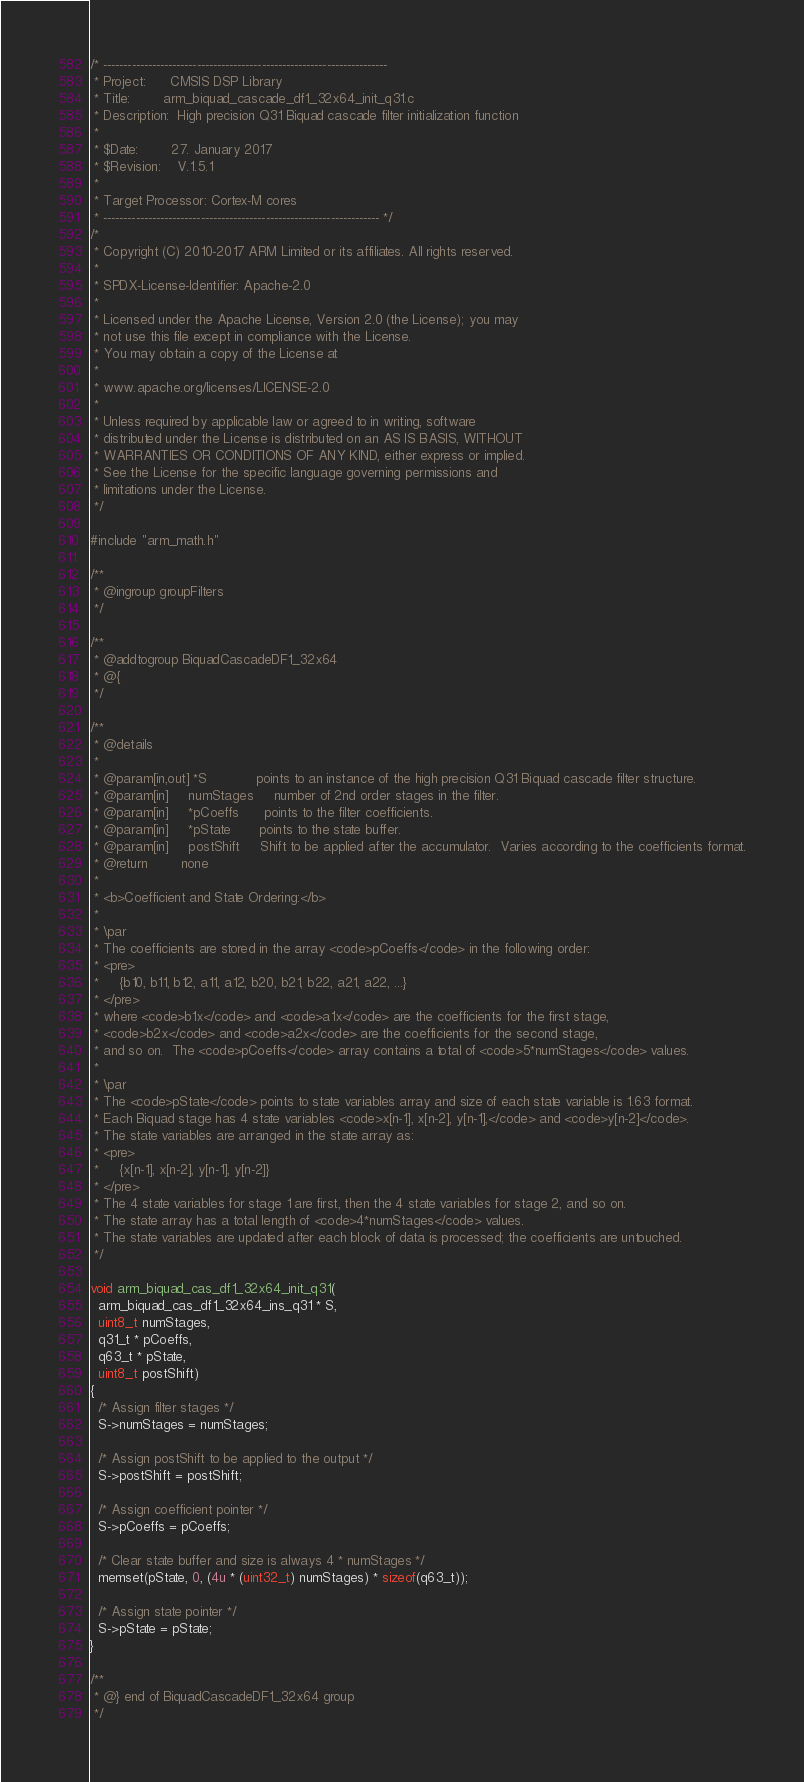<code> <loc_0><loc_0><loc_500><loc_500><_C_>/* ----------------------------------------------------------------------
 * Project:      CMSIS DSP Library
 * Title:        arm_biquad_cascade_df1_32x64_init_q31.c
 * Description:  High precision Q31 Biquad cascade filter initialization function
 *
 * $Date:        27. January 2017
 * $Revision:    V.1.5.1
 *
 * Target Processor: Cortex-M cores
 * -------------------------------------------------------------------- */
/*
 * Copyright (C) 2010-2017 ARM Limited or its affiliates. All rights reserved.
 *
 * SPDX-License-Identifier: Apache-2.0
 *
 * Licensed under the Apache License, Version 2.0 (the License); you may
 * not use this file except in compliance with the License.
 * You may obtain a copy of the License at
 *
 * www.apache.org/licenses/LICENSE-2.0
 *
 * Unless required by applicable law or agreed to in writing, software
 * distributed under the License is distributed on an AS IS BASIS, WITHOUT
 * WARRANTIES OR CONDITIONS OF ANY KIND, either express or implied.
 * See the License for the specific language governing permissions and
 * limitations under the License.
 */

#include "arm_math.h"

/**
 * @ingroup groupFilters
 */

/**
 * @addtogroup BiquadCascadeDF1_32x64
 * @{
 */

/**
 * @details
 *
 * @param[in,out] *S           	points to an instance of the high precision Q31 Biquad cascade filter structure.
 * @param[in]     numStages     number of 2nd order stages in the filter.
 * @param[in]     *pCoeffs      points to the filter coefficients.
 * @param[in]     *pState       points to the state buffer.
 * @param[in]     postShift     Shift to be applied after the accumulator.  Varies according to the coefficients format.
 * @return        none
 *
 * <b>Coefficient and State Ordering:</b>
 *
 * \par
 * The coefficients are stored in the array <code>pCoeffs</code> in the following order:
 * <pre>
 *     {b10, b11, b12, a11, a12, b20, b21, b22, a21, a22, ...}
 * </pre>
 * where <code>b1x</code> and <code>a1x</code> are the coefficients for the first stage,
 * <code>b2x</code> and <code>a2x</code> are the coefficients for the second stage,
 * and so on.  The <code>pCoeffs</code> array contains a total of <code>5*numStages</code> values.
 *
 * \par
 * The <code>pState</code> points to state variables array and size of each state variable is 1.63 format.
 * Each Biquad stage has 4 state variables <code>x[n-1], x[n-2], y[n-1],</code> and <code>y[n-2]</code>.
 * The state variables are arranged in the state array as:
 * <pre>
 *     {x[n-1], x[n-2], y[n-1], y[n-2]}
 * </pre>
 * The 4 state variables for stage 1 are first, then the 4 state variables for stage 2, and so on.
 * The state array has a total length of <code>4*numStages</code> values.
 * The state variables are updated after each block of data is processed; the coefficients are untouched.
 */

void arm_biquad_cas_df1_32x64_init_q31(
  arm_biquad_cas_df1_32x64_ins_q31 * S,
  uint8_t numStages,
  q31_t * pCoeffs,
  q63_t * pState,
  uint8_t postShift)
{
  /* Assign filter stages */
  S->numStages = numStages;

  /* Assign postShift to be applied to the output */
  S->postShift = postShift;

  /* Assign coefficient pointer */
  S->pCoeffs = pCoeffs;

  /* Clear state buffer and size is always 4 * numStages */
  memset(pState, 0, (4u * (uint32_t) numStages) * sizeof(q63_t));

  /* Assign state pointer */
  S->pState = pState;
}

/**
 * @} end of BiquadCascadeDF1_32x64 group
 */
</code> 